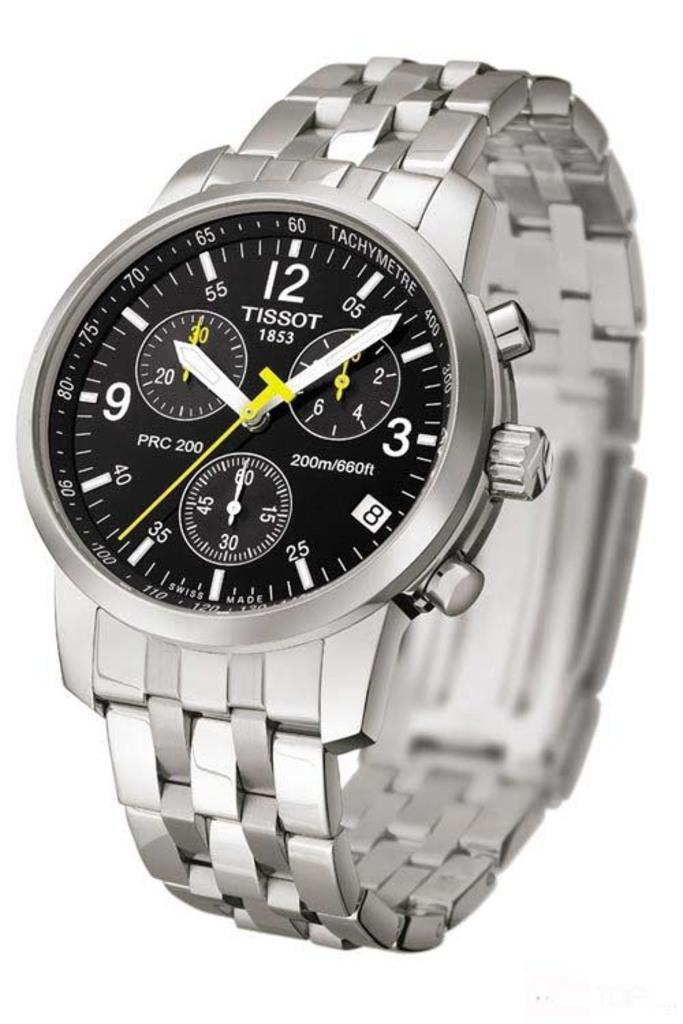<image>
Create a compact narrative representing the image presented. A silver and black TIssot watch displays a time of 10:08. 